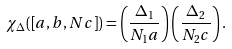<formula> <loc_0><loc_0><loc_500><loc_500>\chi _ { \Delta } ( \left [ a , b , N c \right ] ) = \left ( \frac { \Delta _ { 1 } } { N _ { 1 } a } \right ) \left ( \frac { \Delta _ { 2 } } { N _ { 2 } c } \right ) .</formula> 